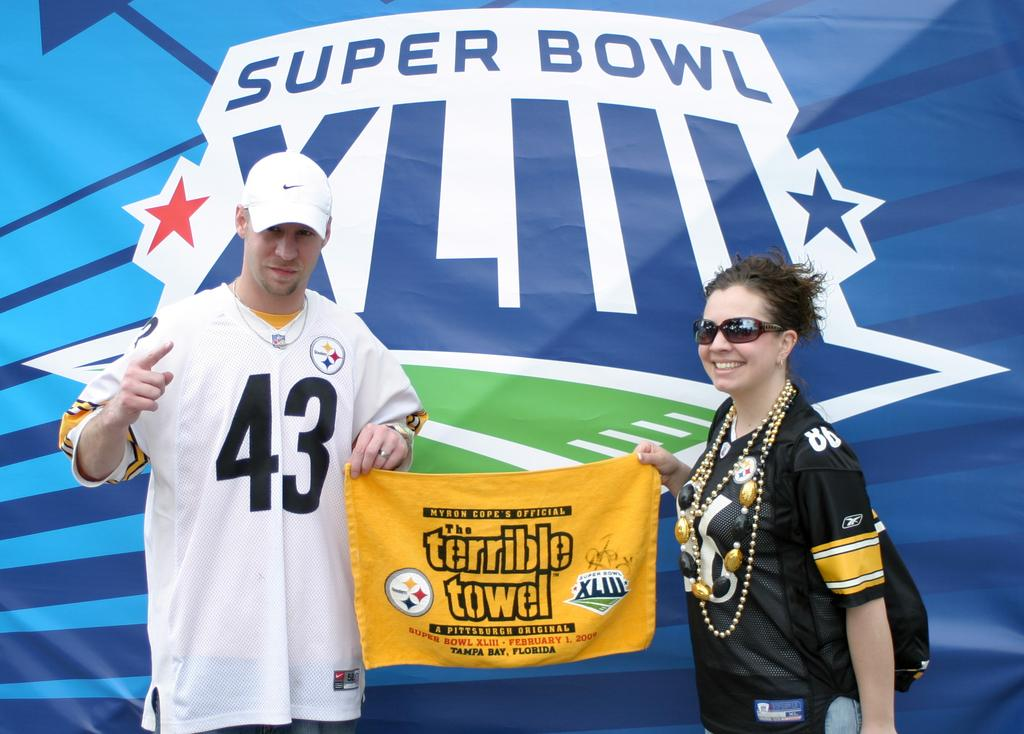<image>
Render a clear and concise summary of the photo. Two people are posing with the terrible towel in front of a Super Bowl XLIII sign. 